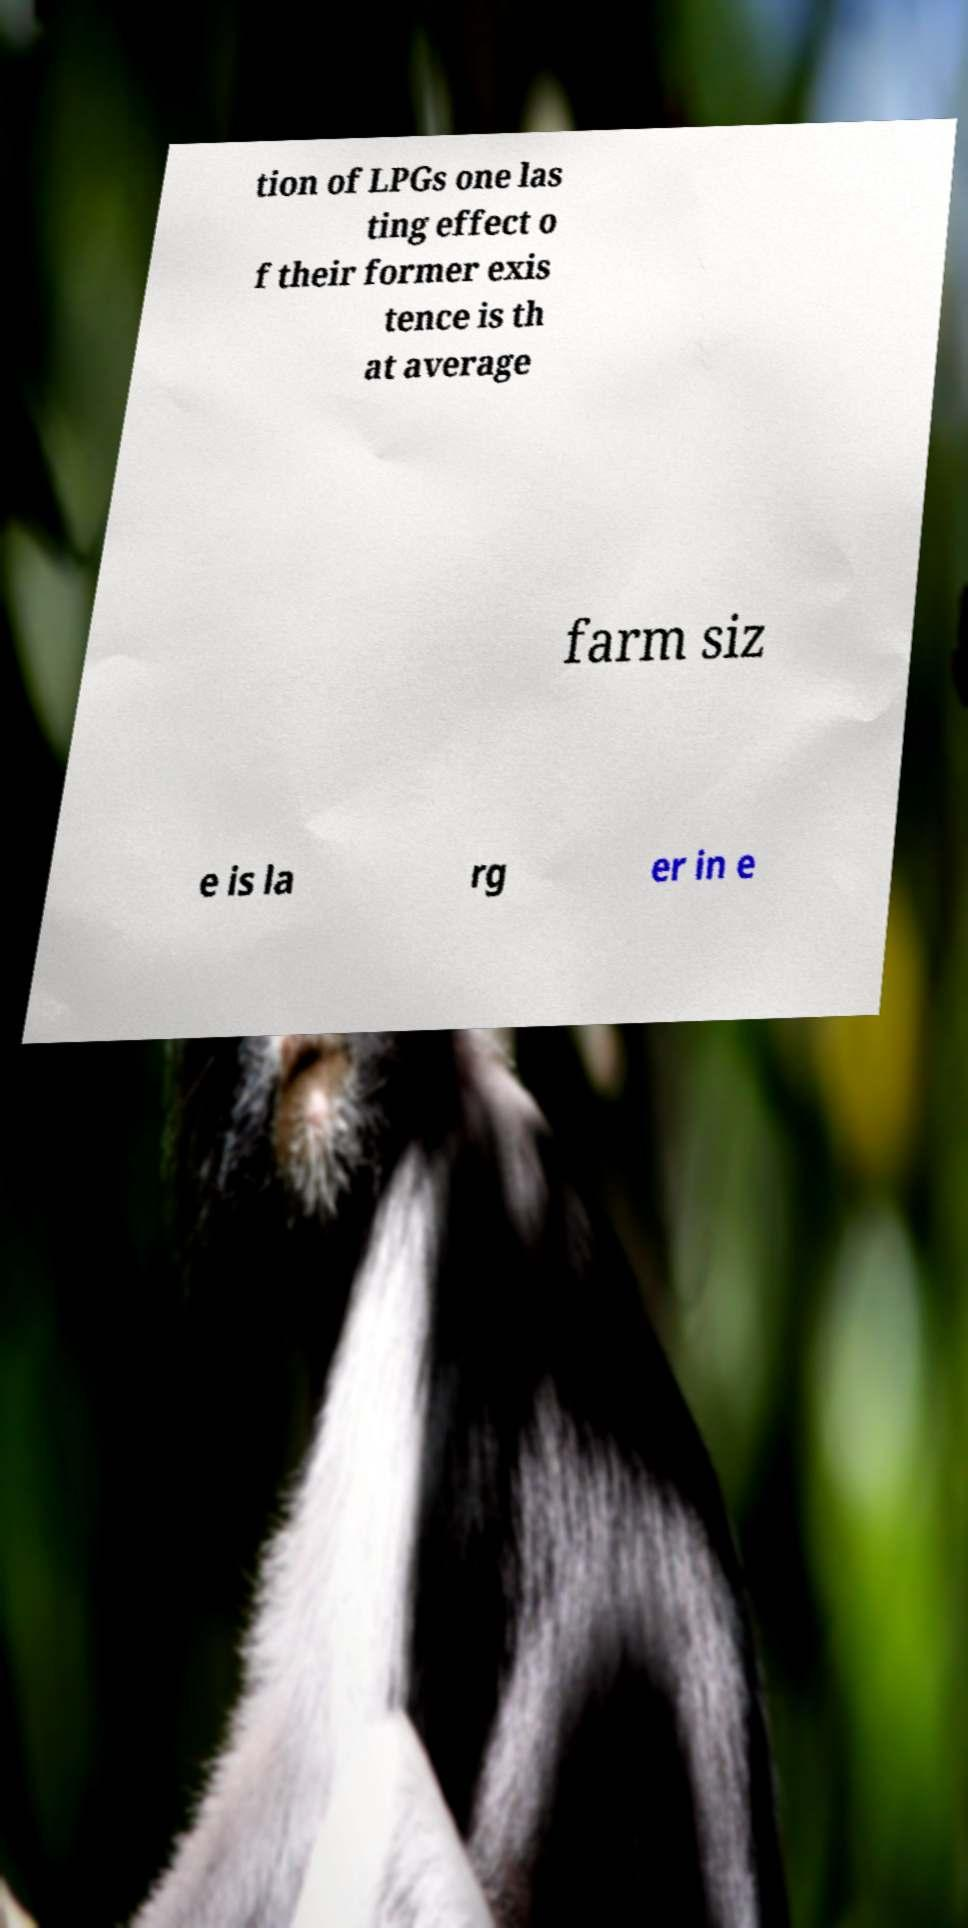For documentation purposes, I need the text within this image transcribed. Could you provide that? tion of LPGs one las ting effect o f their former exis tence is th at average farm siz e is la rg er in e 